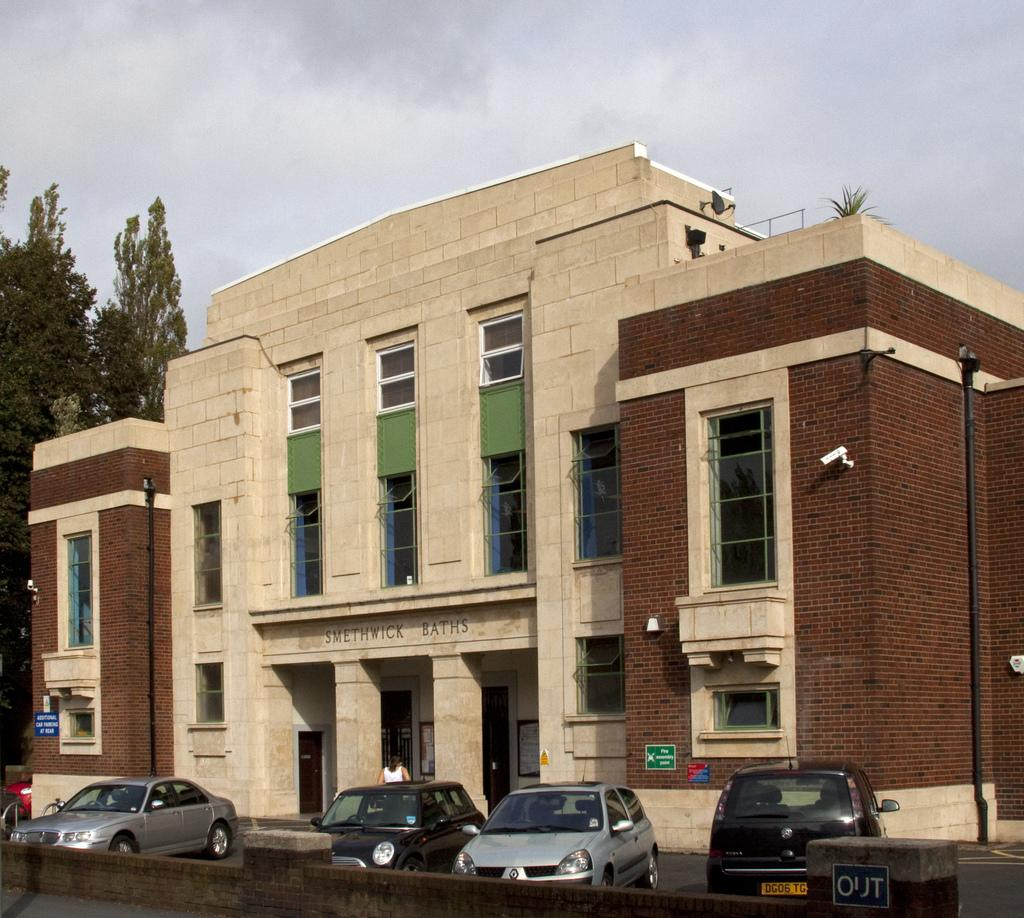What type of structure is visible in the image? There is a building in the image. What can be seen parked near the building? There are cars parked in the image. Is there a person visible in the image? Yes, there is a human in the image. What type of vegetation is present in the image? There are trees in the image. How would you describe the weather based on the image? The sky is cloudy in the image. Are there any security features visible in the image? Yes, there are cameras mounted on the wall in the image. What is the title of the book that the human is reading in the image? There is no book or reading activity visible in the image. Can you describe the cover of the book that the human is holding in the image? There is no book or cover visible in the image. 